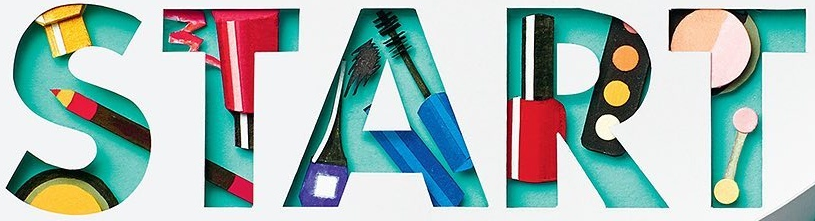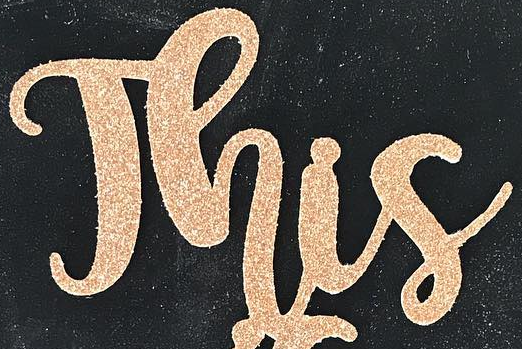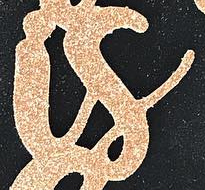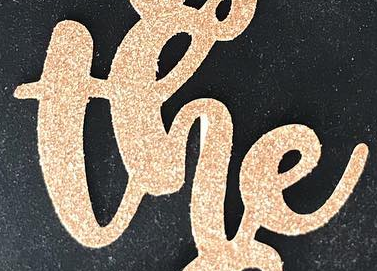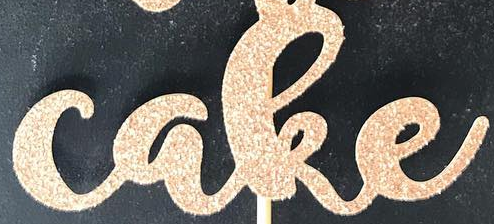What text is displayed in these images sequentially, separated by a semicolon? START; This; is; the; cake 